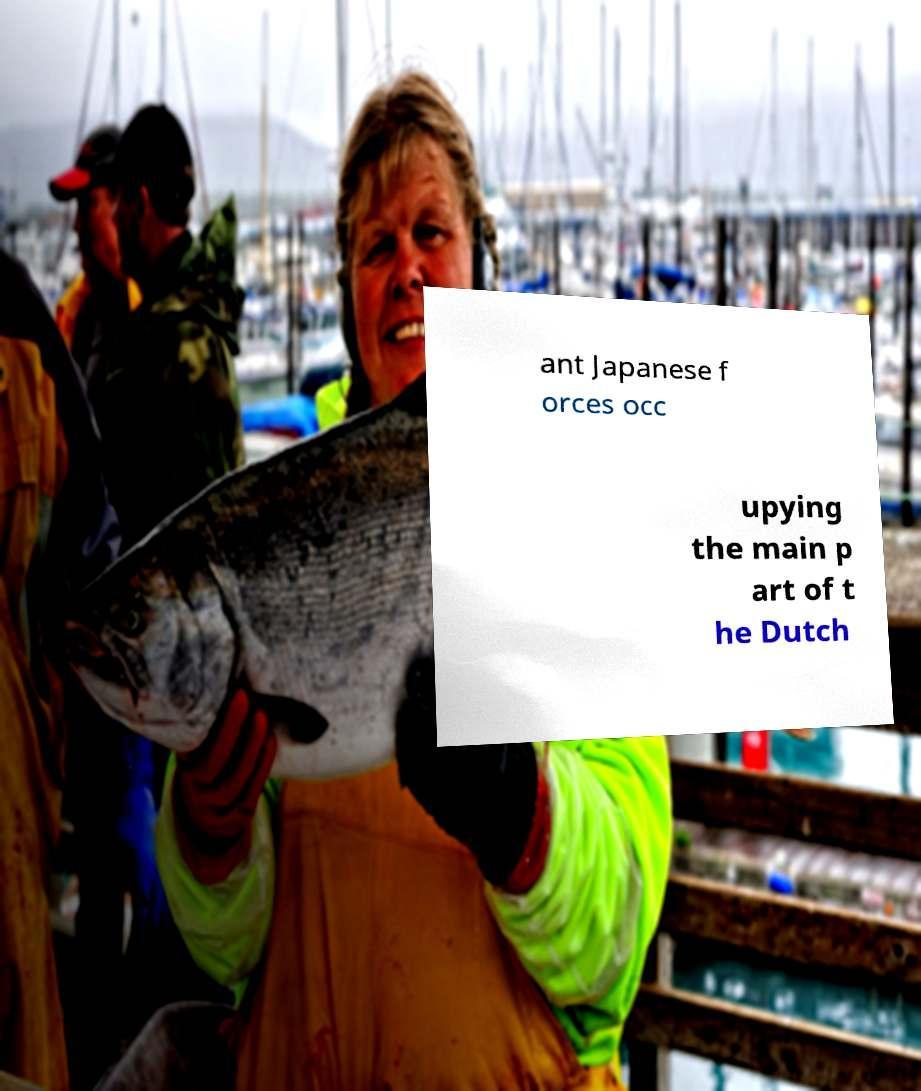For documentation purposes, I need the text within this image transcribed. Could you provide that? ant Japanese f orces occ upying the main p art of t he Dutch 